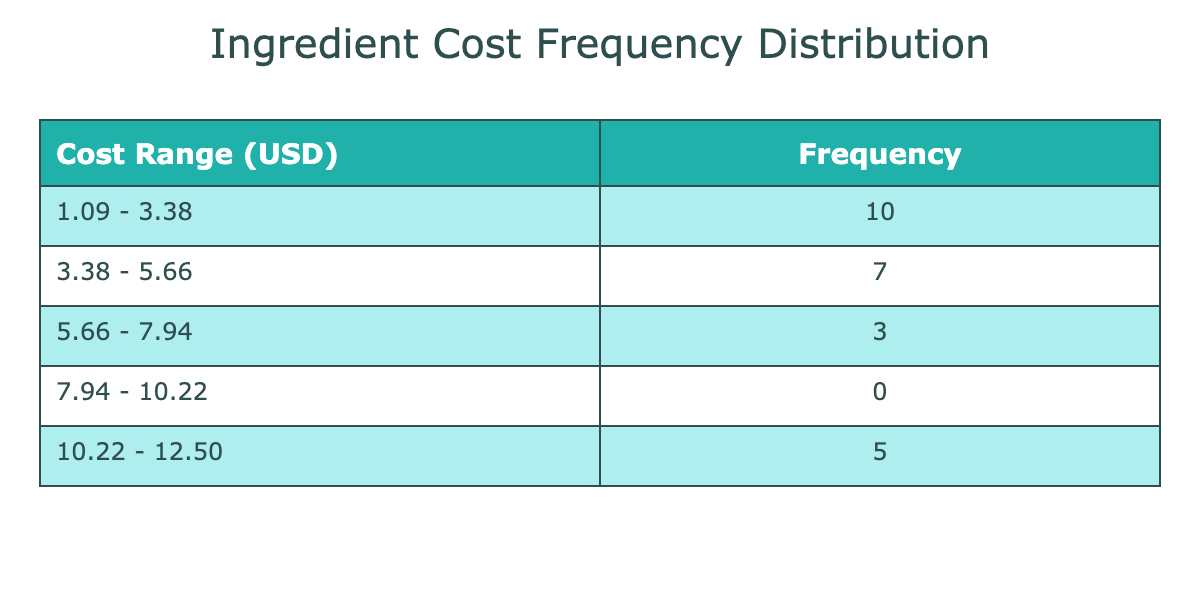What is the cost range that has the highest frequency? To determine the cost range with the highest frequency, I look at the table's frequency column and identify the row with the maximum value. This row indicates the most common cost range for the ingredients listed.
Answer: 2.40 - 3.00 How many suppliers provided ingredients costing between 5.00 to 6.00 USD per unit? I check the frequency distribution table and count the number of occurrences in the range of 5.00 - 6.00 USD. Since this range is included in one of the bins, I look at the corresponding frequency value to derive the total number of suppliers in this cost range.
Answer: 5 Is there a cost range that contains only one ingredient? By examining each cost range in the table and reviewing the frequencies, I can confirm whether any range has a frequency of only one occurrence. Upon checking, there are ranges where only a single ingredient cost is represented.
Answer: Yes What is the total frequency of ingredients that cost below 3.00 USD? I need to identify the cost ranges below 3.00 USD by checking the table. I'll sum up the frequencies of all ranges that meet this criterion to find out the total frequency of those ingredients.
Answer: 6 What is the average cost per unit of all ingredients listed? First, I sum the individual costs of all ingredients provided. Then, I divide this total by the number of unique ingredients to calculate the average cost. This requires me to carefully note down the prices and perform the calculation. The total is 79.75, and there are 20 data points, hence the average is 79.75 / 20.
Answer: 3.99 What is the most expensive ingredient and its cost? In the table, I need to identify which ingredient has the highest cost from all the variations present. By checking through the costs, I see that Olive Oil from Harvest Time Oils is the highest.
Answer: Olive Oil, 12.50 How many suppliers fall into the cost range of 10.00 to 13.00 USD? I analyze the frequency table and find the count of ingredients that fall into the cost range of 10.00 to 13.00 USD. By identifying the correct range, I can ascertain the respective frequency.
Answer: 5 Do any suppliers offer Basil at a lower cost than the cheapest supplier of Chicken Breast? The cheapest supplier of Chicken Breast is Free Range Co. at 5.25 USD. I check the Basil suppliers' costs to see if any offer it at a lower price. Two Basil suppliers have costs below that, thus confirming the assertion.
Answer: Yes 